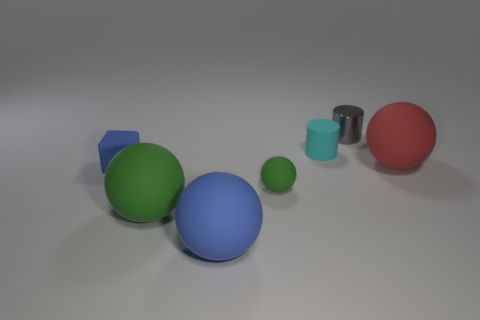Subtract all red cylinders. How many green balls are left? 2 Subtract all large matte balls. How many balls are left? 1 Subtract 2 spheres. How many spheres are left? 2 Subtract all red spheres. How many spheres are left? 3 Add 2 rubber cylinders. How many objects exist? 9 Subtract all cyan spheres. Subtract all brown cylinders. How many spheres are left? 4 Subtract all balls. How many objects are left? 3 Subtract 0 purple cubes. How many objects are left? 7 Subtract all rubber cubes. Subtract all big blue matte balls. How many objects are left? 5 Add 5 tiny gray objects. How many tiny gray objects are left? 6 